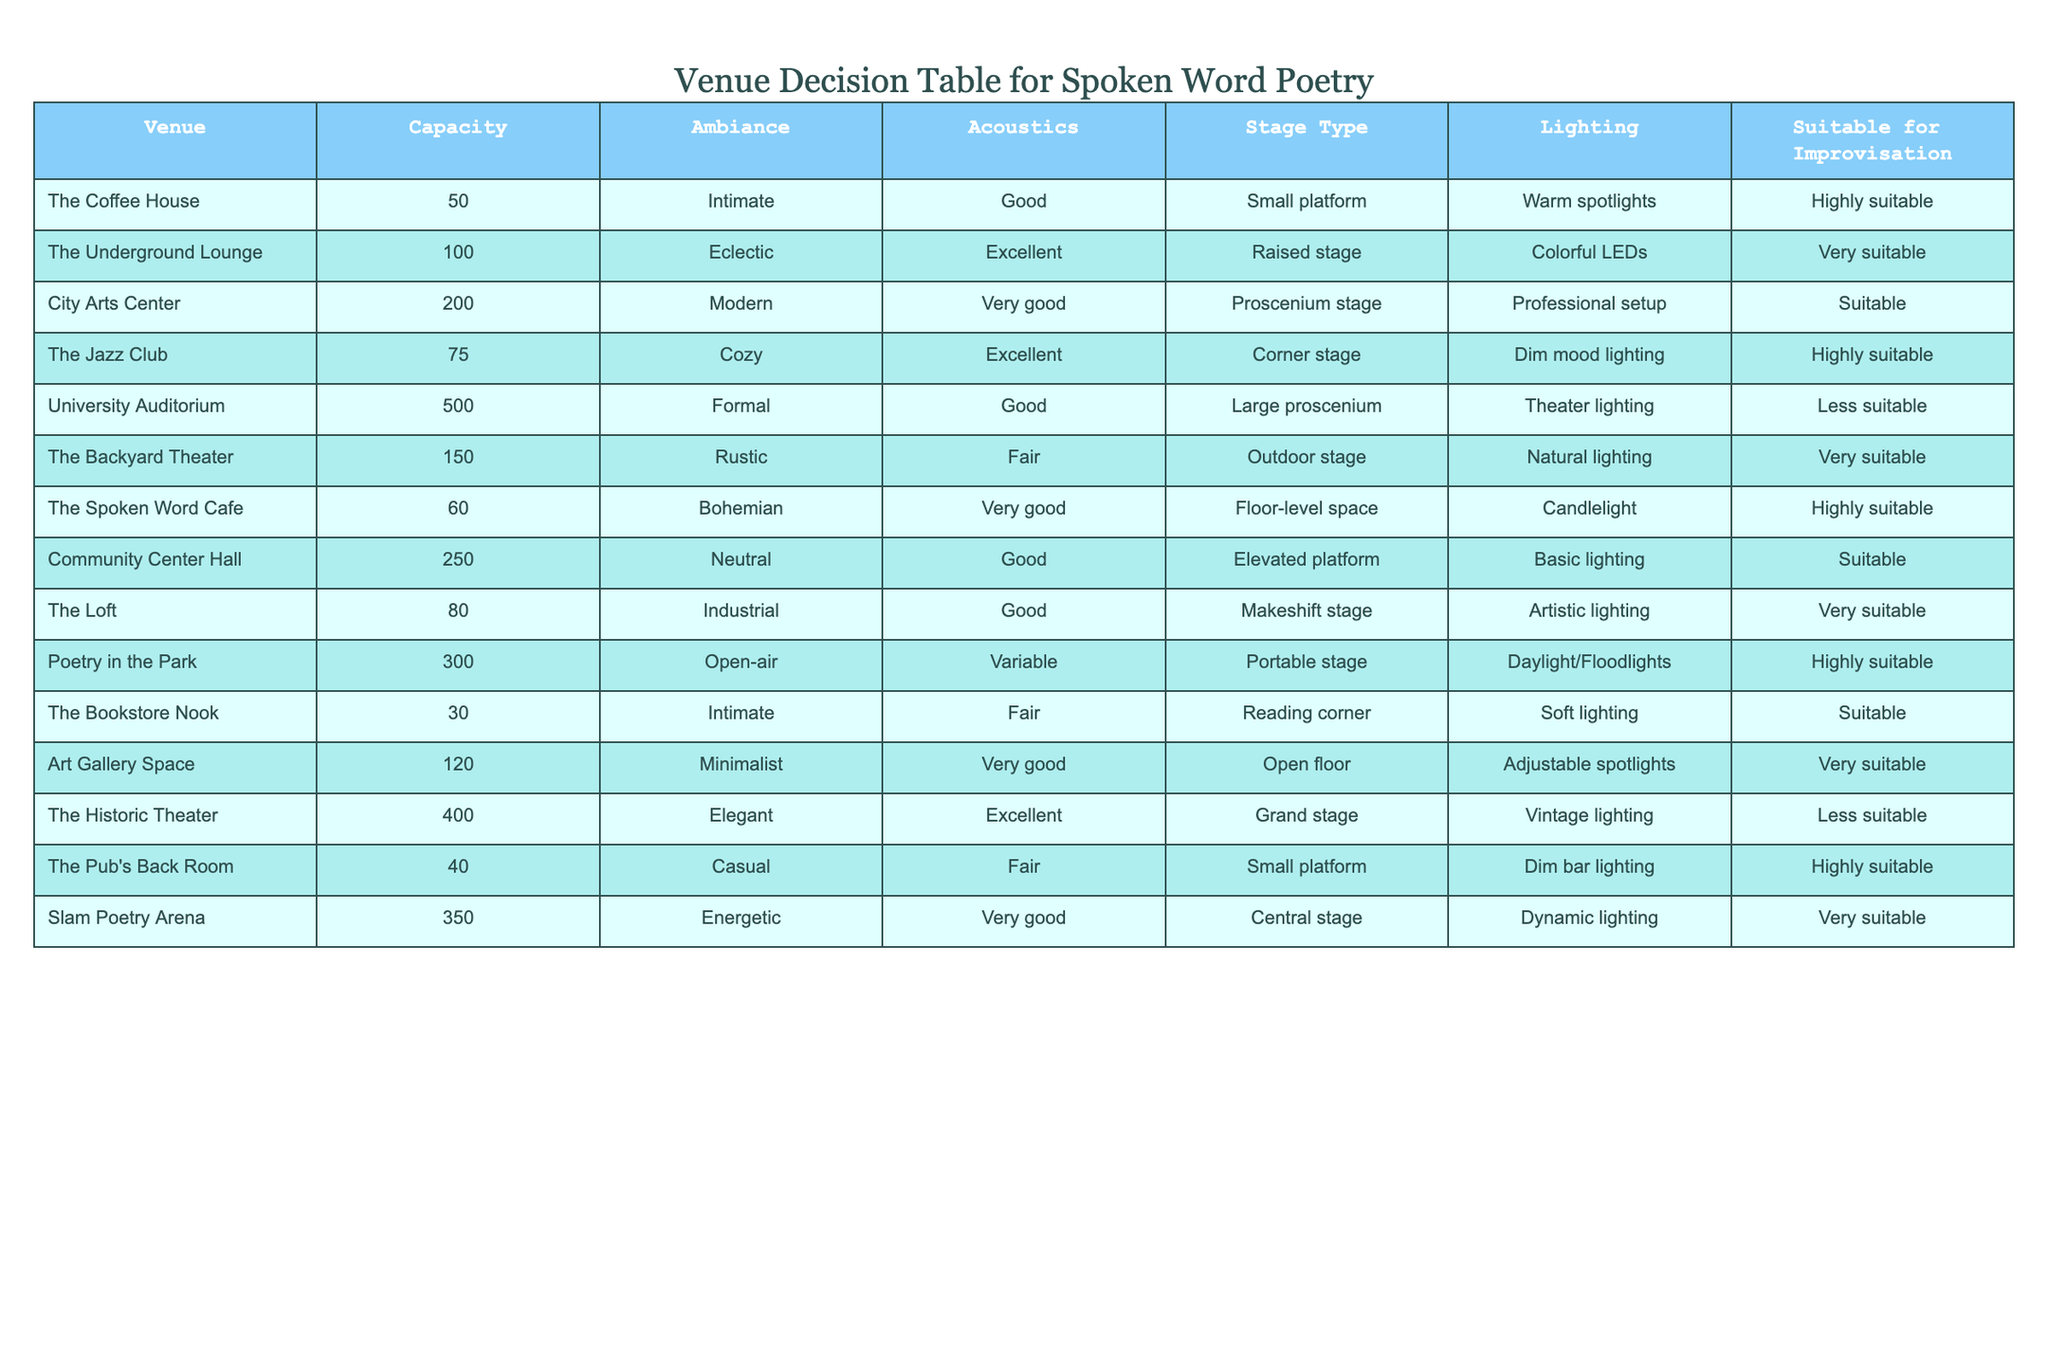What is the capacity of The Jazz Club? The table shows a row for The Jazz Club, and under the "Capacity" column, it lists the number 75.
Answer: 75 Which venues are highly suitable for improvisation? By scanning the "Suitable for Improvisation" column, the venues marked as "Highly suitable" are The Coffee House, The Jazz Club, The Spoken Word Cafe, The Pub's Back Room, and Poetry in the Park.
Answer: The Coffee House, The Jazz Club, The Spoken Word Cafe, The Pub's Back Room, Poetry in the Park How many venues have a capacity of 200 or more? The venues with the listed capacities of 200 or more are City Arts Center (200), Community Center Hall (250), University Auditorium (500), The Historic Theater (400), and Slam Poetry Arena (350). There are a total of 5 venues that fit this criterion.
Answer: 5 What is the average capacity of the venues that have "Very suitable" for improvisation? The venues that are "Very suitable" for improvisation include The Underground Lounge (100), The Backyard Theater (150), The Loft (80), Art Gallery Space (120), Slam Poetry Arena (350), and Poetry in the Park (300). Their capacities are summed: 100 + 150 + 80 + 120 + 350 + 300 = 1100. Since there are 6 venues, the average capacity is 1100 / 6 = 183.33.
Answer: 183.33 Is The Spoken Word Cafe more intimate than The Pub's Back Room? The table indicates that The Spoken Word Cafe has a capacity of 60, and The Pub's Back Room has a capacity of 40. Since 60 is greater than 40, The Spoken Word Cafe is not more intimate; it is less intimate.
Answer: No Which venue has the best acoustics and what is its capacity? Analyzing the "Acoustics" column, the venue with "Excellent" acoustics is The Jazz Club (75), The Underground Lounge (100), and The Historic Theater (400). The highest capacity among these is The Historic Theater with 400.
Answer: The Historic Theater, 400 